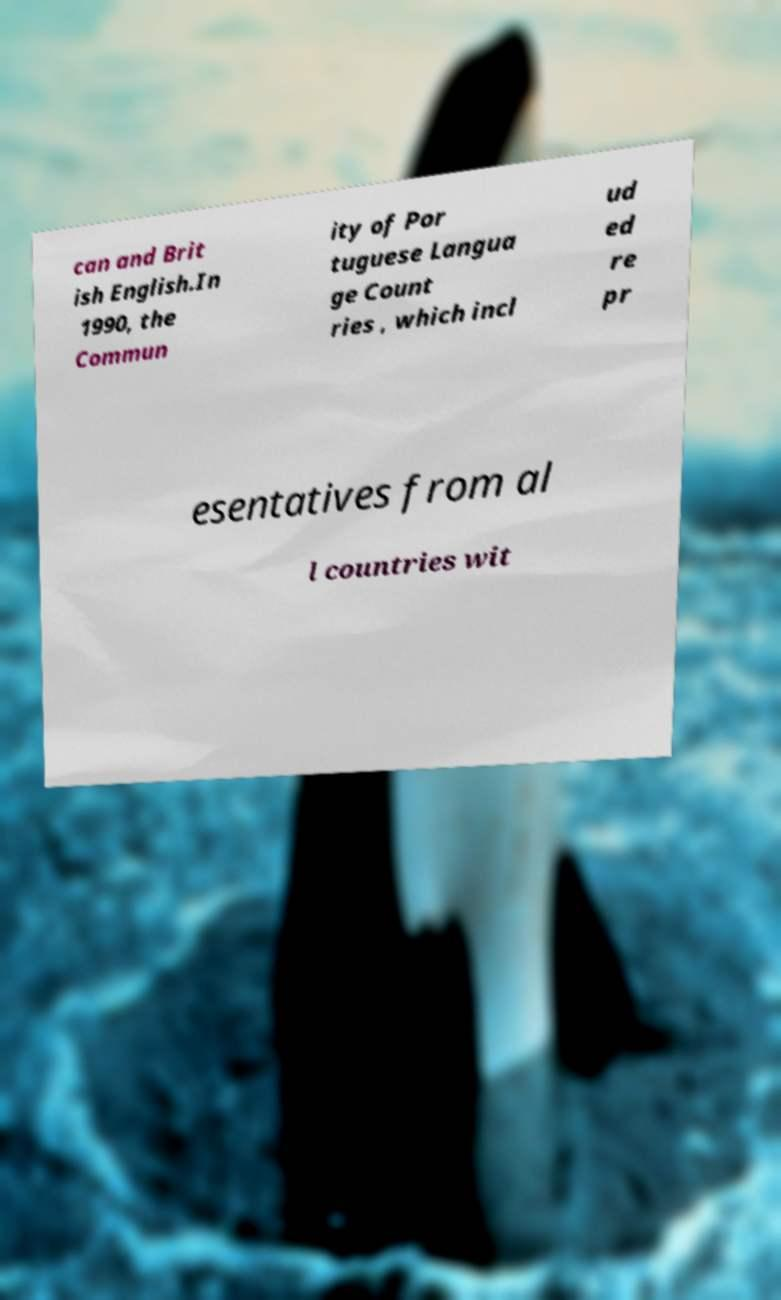Please identify and transcribe the text found in this image. can and Brit ish English.In 1990, the Commun ity of Por tuguese Langua ge Count ries , which incl ud ed re pr esentatives from al l countries wit 